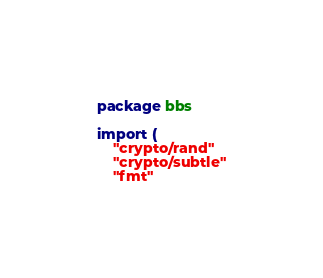Convert code to text. <code><loc_0><loc_0><loc_500><loc_500><_Go_>package bbs

import (
	"crypto/rand"
	"crypto/subtle"
	"fmt"</code> 